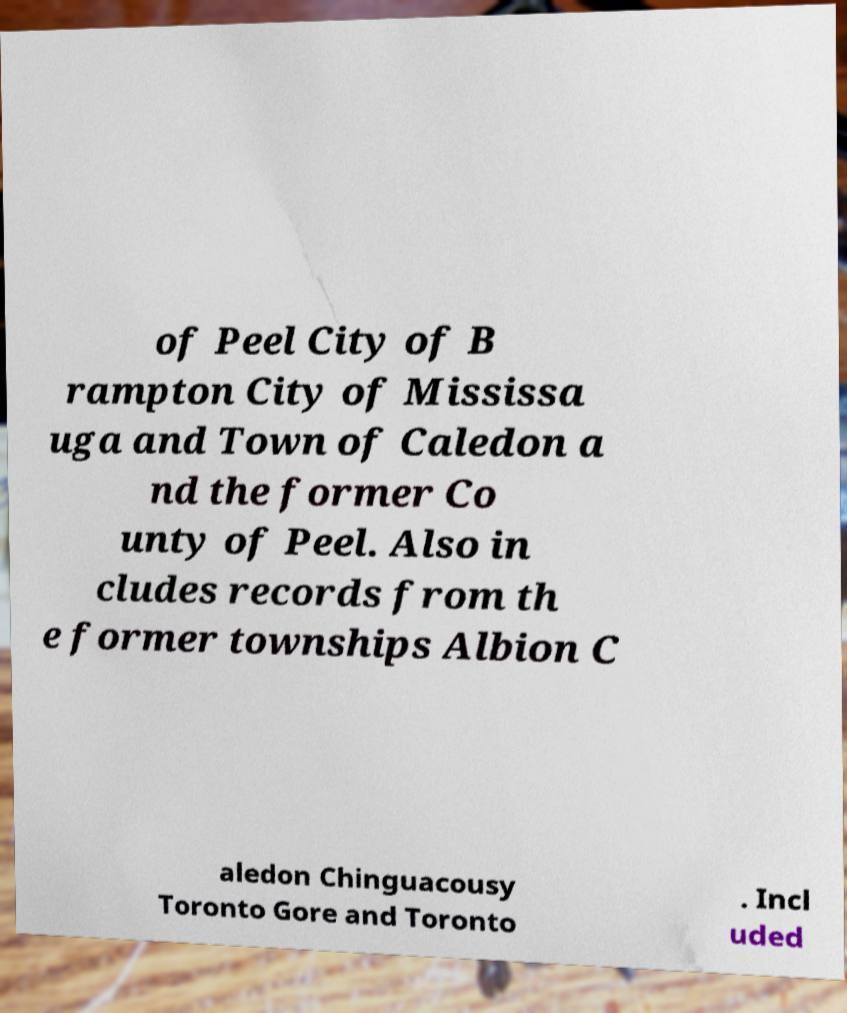What messages or text are displayed in this image? I need them in a readable, typed format. of Peel City of B rampton City of Mississa uga and Town of Caledon a nd the former Co unty of Peel. Also in cludes records from th e former townships Albion C aledon Chinguacousy Toronto Gore and Toronto . Incl uded 